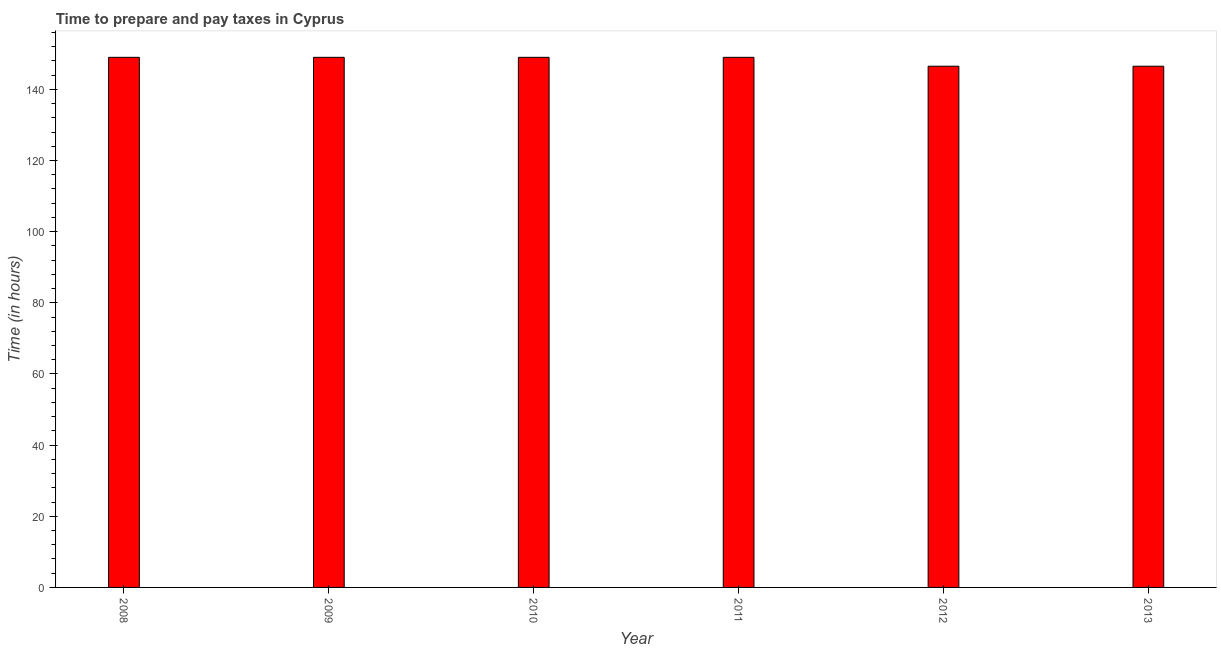Does the graph contain grids?
Your answer should be very brief. No. What is the title of the graph?
Provide a succinct answer. Time to prepare and pay taxes in Cyprus. What is the label or title of the Y-axis?
Provide a succinct answer. Time (in hours). What is the time to prepare and pay taxes in 2011?
Ensure brevity in your answer.  149. Across all years, what is the maximum time to prepare and pay taxes?
Your answer should be compact. 149. Across all years, what is the minimum time to prepare and pay taxes?
Make the answer very short. 146.5. In which year was the time to prepare and pay taxes maximum?
Make the answer very short. 2008. What is the sum of the time to prepare and pay taxes?
Offer a terse response. 889. What is the difference between the time to prepare and pay taxes in 2010 and 2011?
Provide a short and direct response. 0. What is the average time to prepare and pay taxes per year?
Offer a very short reply. 148.17. What is the median time to prepare and pay taxes?
Keep it short and to the point. 149. In how many years, is the time to prepare and pay taxes greater than 108 hours?
Offer a terse response. 6. Do a majority of the years between 2008 and 2013 (inclusive) have time to prepare and pay taxes greater than 56 hours?
Offer a terse response. Yes. What is the ratio of the time to prepare and pay taxes in 2009 to that in 2012?
Offer a terse response. 1.02. Is the sum of the time to prepare and pay taxes in 2008 and 2012 greater than the maximum time to prepare and pay taxes across all years?
Ensure brevity in your answer.  Yes. How many bars are there?
Your answer should be compact. 6. How many years are there in the graph?
Ensure brevity in your answer.  6. What is the difference between two consecutive major ticks on the Y-axis?
Ensure brevity in your answer.  20. Are the values on the major ticks of Y-axis written in scientific E-notation?
Your answer should be very brief. No. What is the Time (in hours) of 2008?
Offer a terse response. 149. What is the Time (in hours) in 2009?
Make the answer very short. 149. What is the Time (in hours) of 2010?
Your response must be concise. 149. What is the Time (in hours) of 2011?
Make the answer very short. 149. What is the Time (in hours) in 2012?
Keep it short and to the point. 146.5. What is the Time (in hours) in 2013?
Ensure brevity in your answer.  146.5. What is the difference between the Time (in hours) in 2008 and 2009?
Your answer should be very brief. 0. What is the difference between the Time (in hours) in 2008 and 2010?
Offer a terse response. 0. What is the difference between the Time (in hours) in 2008 and 2012?
Give a very brief answer. 2.5. What is the difference between the Time (in hours) in 2008 and 2013?
Offer a very short reply. 2.5. What is the difference between the Time (in hours) in 2009 and 2012?
Keep it short and to the point. 2.5. What is the difference between the Time (in hours) in 2010 and 2011?
Your answer should be compact. 0. What is the difference between the Time (in hours) in 2011 and 2012?
Ensure brevity in your answer.  2.5. What is the difference between the Time (in hours) in 2011 and 2013?
Provide a succinct answer. 2.5. What is the difference between the Time (in hours) in 2012 and 2013?
Your response must be concise. 0. What is the ratio of the Time (in hours) in 2008 to that in 2010?
Your answer should be compact. 1. What is the ratio of the Time (in hours) in 2008 to that in 2012?
Your response must be concise. 1.02. What is the ratio of the Time (in hours) in 2008 to that in 2013?
Your answer should be compact. 1.02. What is the ratio of the Time (in hours) in 2009 to that in 2010?
Give a very brief answer. 1. What is the ratio of the Time (in hours) in 2010 to that in 2012?
Give a very brief answer. 1.02. What is the ratio of the Time (in hours) in 2010 to that in 2013?
Keep it short and to the point. 1.02. What is the ratio of the Time (in hours) in 2011 to that in 2012?
Give a very brief answer. 1.02. What is the ratio of the Time (in hours) in 2012 to that in 2013?
Offer a terse response. 1. 